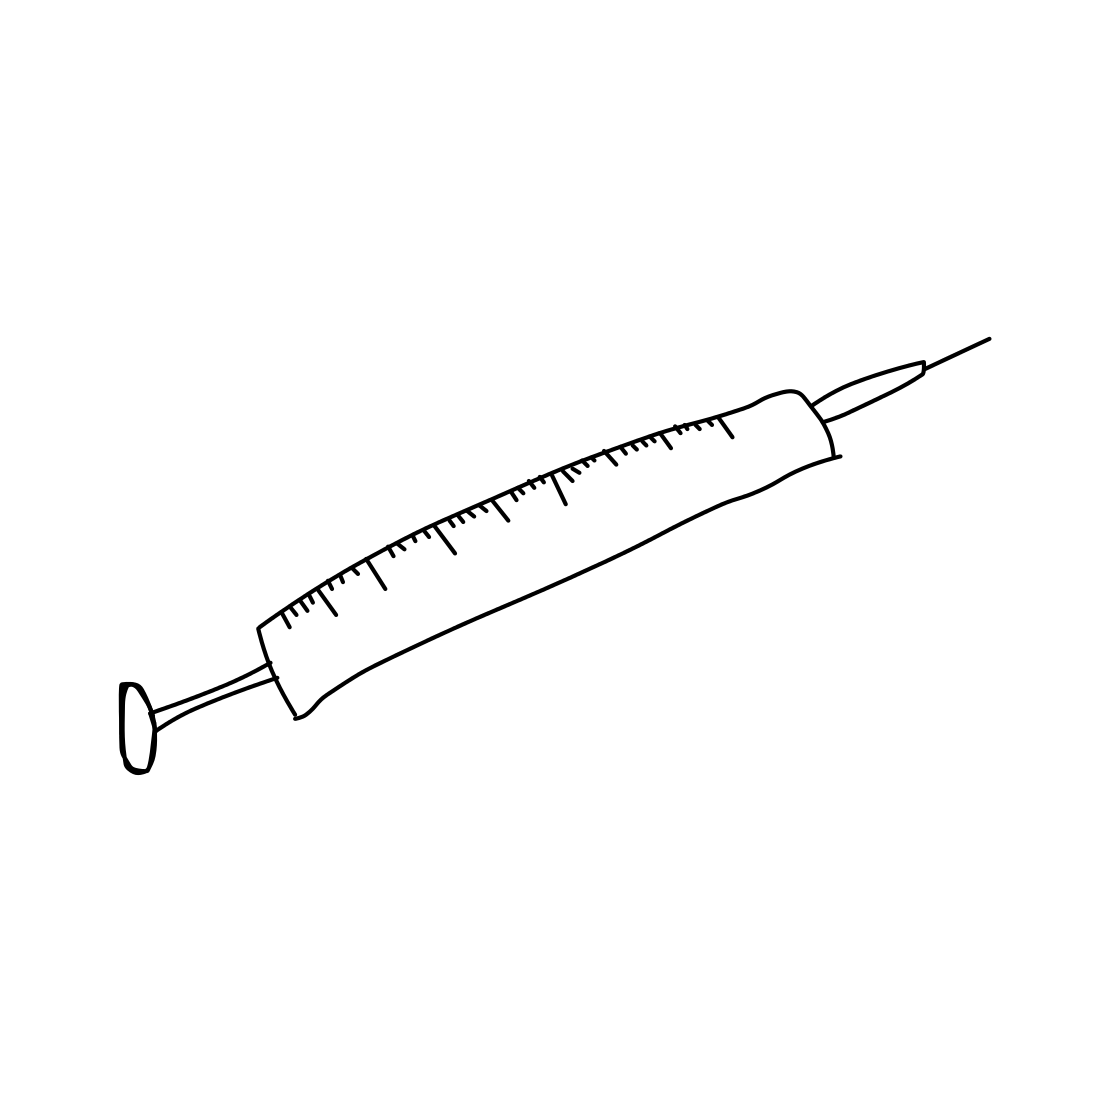What are the components of a syringe as shown in the image, and how do they function together? A typical syringe, such as the one in the image, consists of three main components: the needle, the barrel, and the plunger. The needle is a fine, hollow tube that penetrates the body's tissue. The barrel holds the fluid that will be injected or drawn from the body, and it typically has measurement markings for dosing accuracy. The plunger fits snugly within the barrel and can be pulled back to draw in fluid or pushed forward to inject fluid. These parts work in unison to either administer medication or vaccines, or to collect samples of blood or other fluids for testing. 